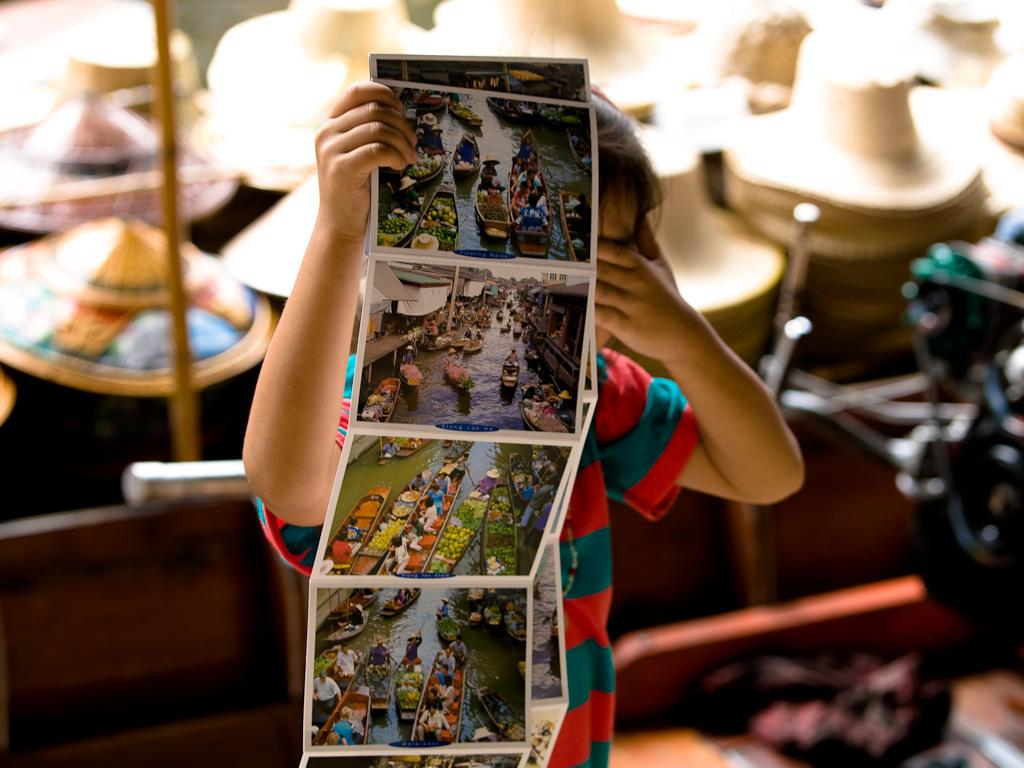What is the main subject of the image? The main subject of the image is a kid. What is the kid holding in the image? The kid is holding photographs. Can you describe the background of the image? The background of the image is blurry. What type of accessory can be seen in the image? There are hats visible in the image. What is the tall, vertical object in the image? There is a pole in the image. Are there any other objects present in the image besides the ones mentioned? Yes, there are other objects present in the image. What type of berry is being picked in the garden in the image? There is no garden or berries present in the image. 